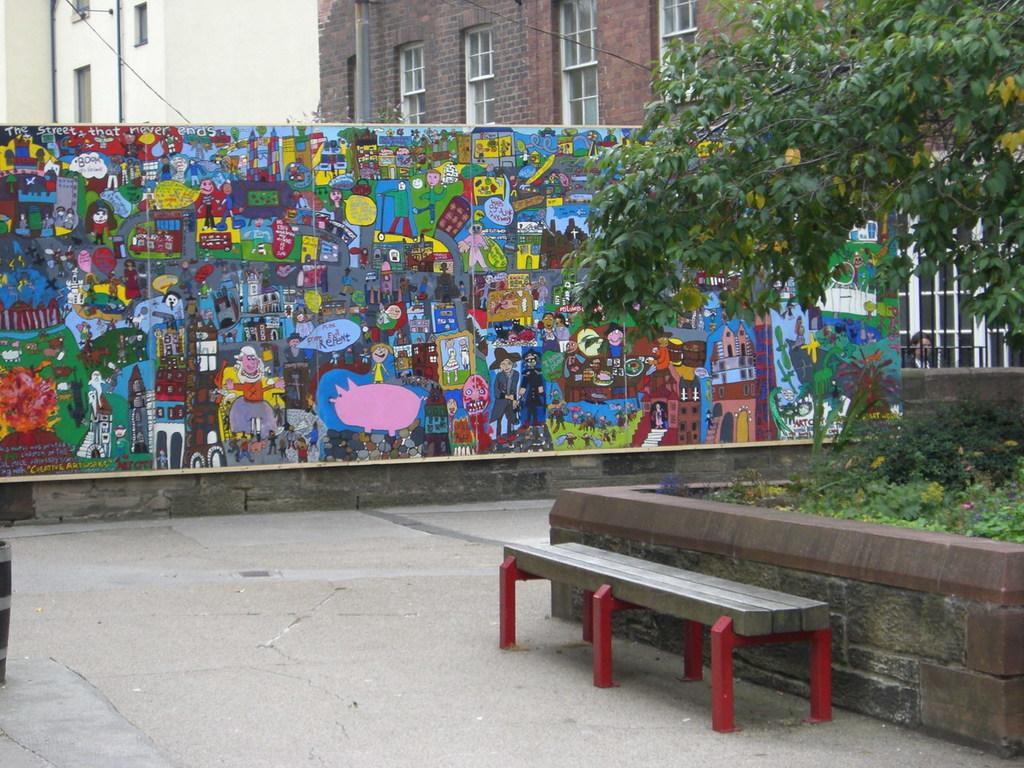How would you summarize this image in a sentence or two? At the bottom of the picture, we see the bench is placed on the road. Beside that, we see plants and trees. Behind that, we see a wall painted cartoons. In the background, we see buildings which are in white and brown color. 